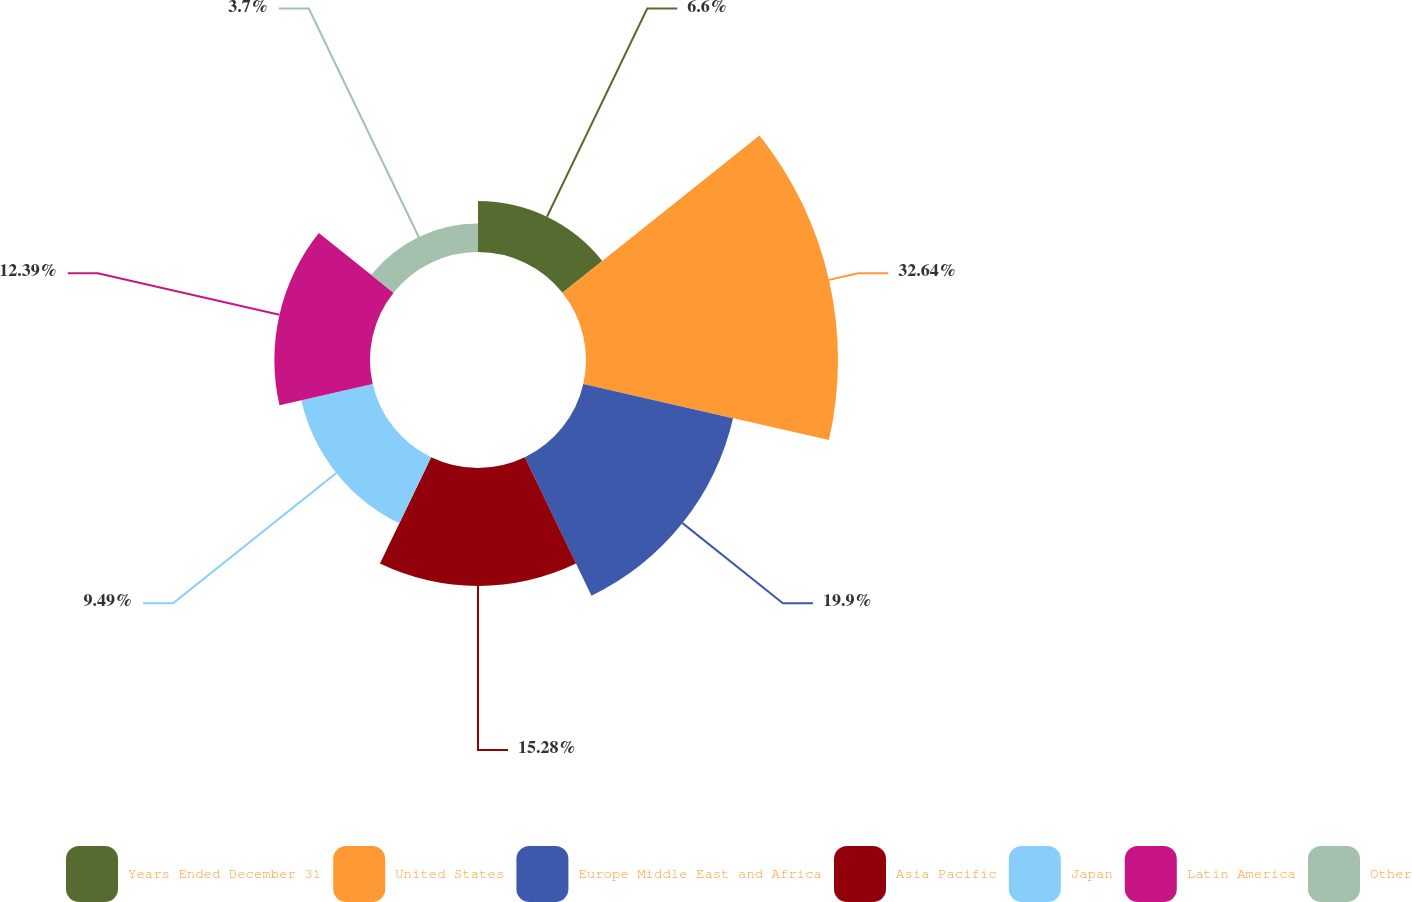<chart> <loc_0><loc_0><loc_500><loc_500><pie_chart><fcel>Years Ended December 31<fcel>United States<fcel>Europe Middle East and Africa<fcel>Asia Pacific<fcel>Japan<fcel>Latin America<fcel>Other<nl><fcel>6.6%<fcel>32.65%<fcel>19.9%<fcel>15.28%<fcel>9.49%<fcel>12.39%<fcel>3.7%<nl></chart> 